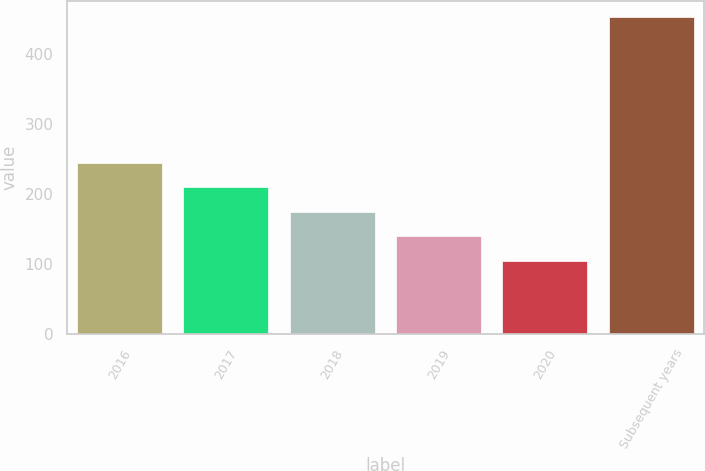<chart> <loc_0><loc_0><loc_500><loc_500><bar_chart><fcel>2016<fcel>2017<fcel>2018<fcel>2019<fcel>2020<fcel>Subsequent years<nl><fcel>244.2<fcel>209.4<fcel>174.6<fcel>139.8<fcel>105<fcel>453<nl></chart> 